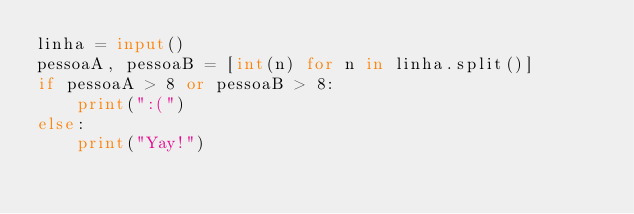Convert code to text. <code><loc_0><loc_0><loc_500><loc_500><_Python_>linha = input()
pessoaA, pessoaB = [int(n) for n in linha.split()]
if pessoaA > 8 or pessoaB > 8:
    print(":(")
else:
    print("Yay!")
</code> 